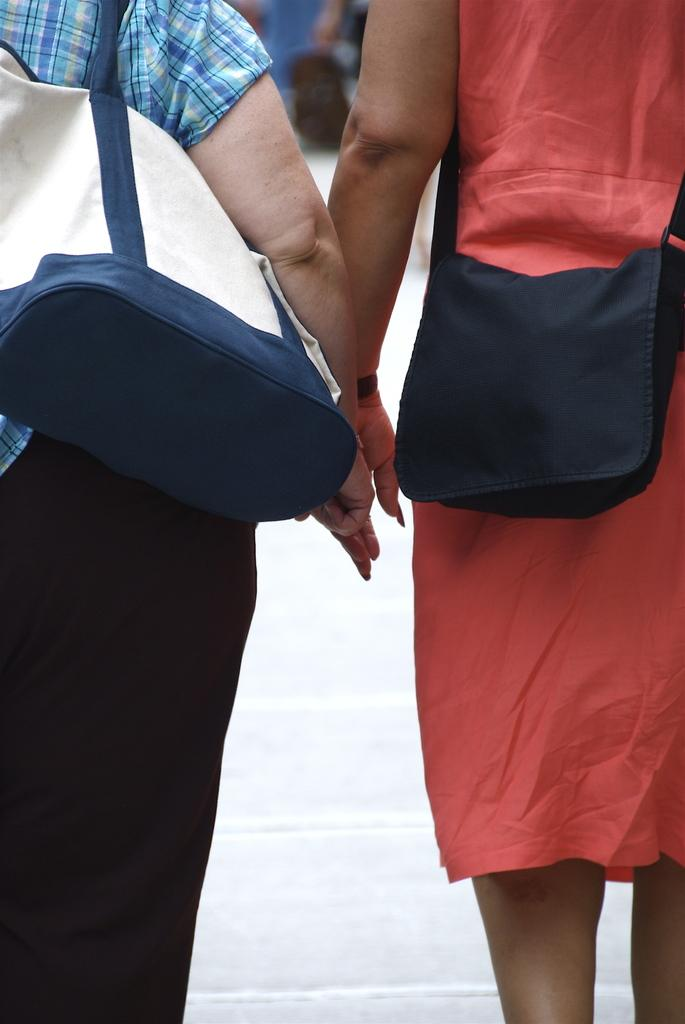How many people are in the image? There are two women in the image. What are the women doing in the image? The women are standing. What accessories are the women wearing in the image? The women are wearing handbags. What type of brush can be seen in the hands of the women in the image? There is no brush present in the image; the women are not holding any objects. 